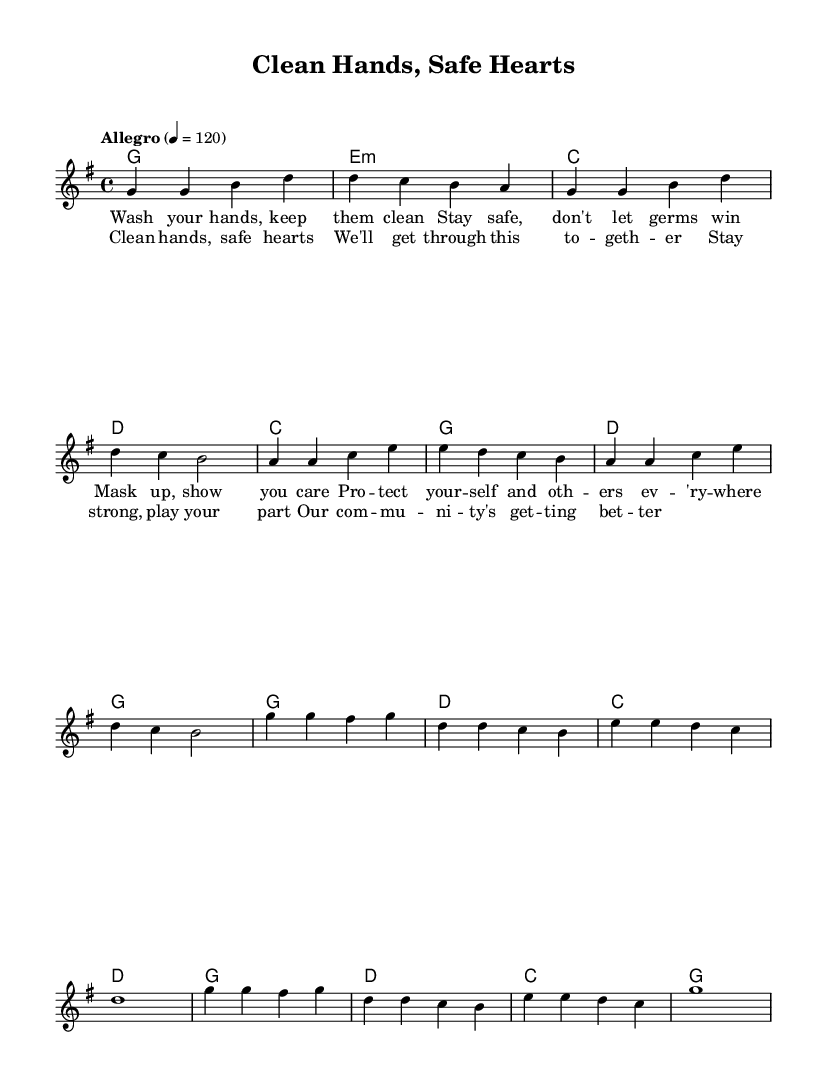What is the key signature of this music? The key signature is G major, which has one sharp (F#).
Answer: G major What is the time signature of this piece? The time signature is 4/4, indicating there are four beats in each measure.
Answer: 4/4 What is the tempo marking of the music? The tempo marking indicates "Allegro" at a speed of 120 beats per minute.
Answer: Allegro 120 How many measures are in the verse section? The verse section consists of eight measures based on the way the melody is grouped.
Answer: Eight measures What are the main themes of the lyrics? The lyrics focus on hygiene and community safety, promoting actions like washing hands and wearing masks.
Answer: Hygiene and safety How does the chorus contrast with the verse musically? The chorus features a more uplifting message with repeated phrases that create a sense of unity, compared to the descriptive verses.
Answer: Uplifting and unifying What K-Pop characteristics are reflected in the melody structure? The melody incorporates catchy, repetitive phrases typical in K-Pop, designed to be memorable and singable.
Answer: Catchy and repetitive 